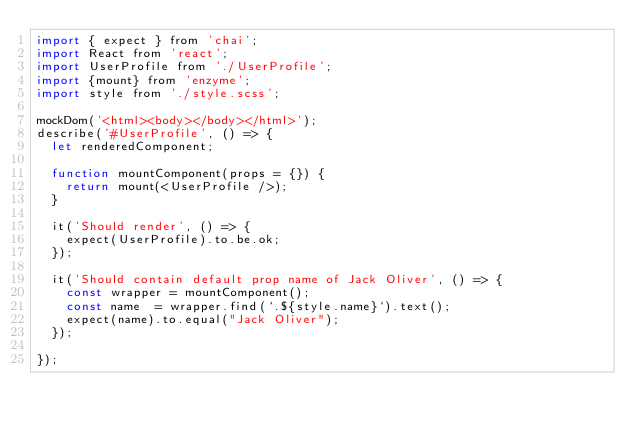Convert code to text. <code><loc_0><loc_0><loc_500><loc_500><_JavaScript_>import { expect } from 'chai';
import React from 'react';
import UserProfile from './UserProfile';
import {mount} from 'enzyme';
import style from './style.scss';

mockDom('<html><body></body></html>');
describe('#UserProfile', () => {
  let renderedComponent;

  function mountComponent(props = {}) {
    return mount(<UserProfile />);
  }

  it('Should render', () => {
    expect(UserProfile).to.be.ok;
  });

  it('Should contain default prop name of Jack Oliver', () => {
    const wrapper = mountComponent();
    const name  = wrapper.find(`.${style.name}`).text();
    expect(name).to.equal("Jack Oliver");
  });

});
</code> 